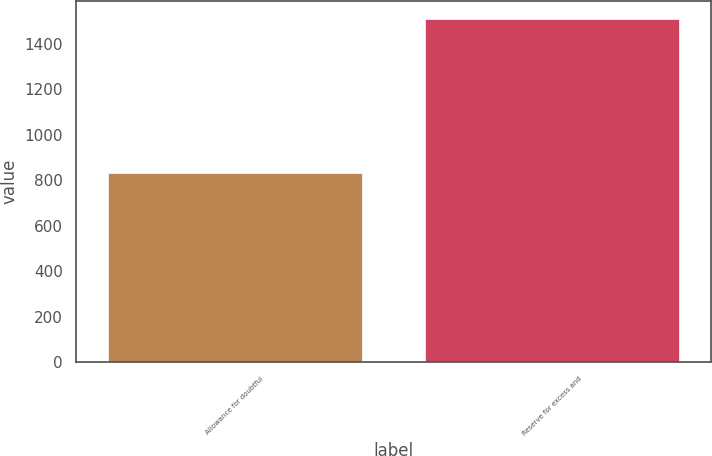Convert chart to OTSL. <chart><loc_0><loc_0><loc_500><loc_500><bar_chart><fcel>Allowance for doubtful<fcel>Reserve for excess and<nl><fcel>834<fcel>1512<nl></chart> 